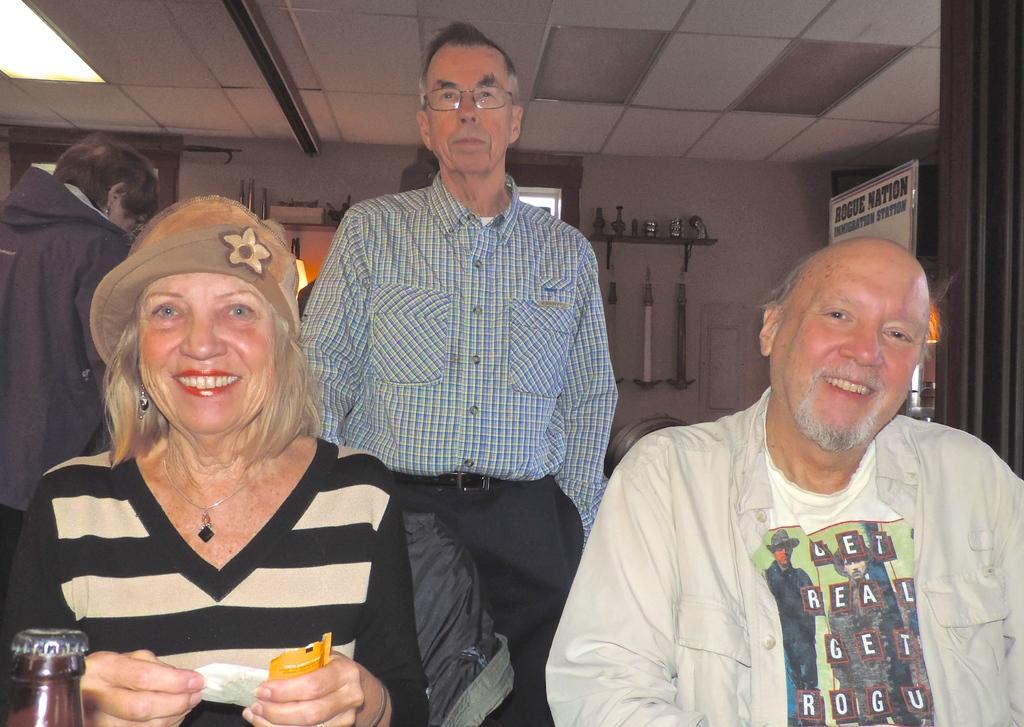What does the sign behind the man's head say?
Provide a short and direct response. Rogue nation. 